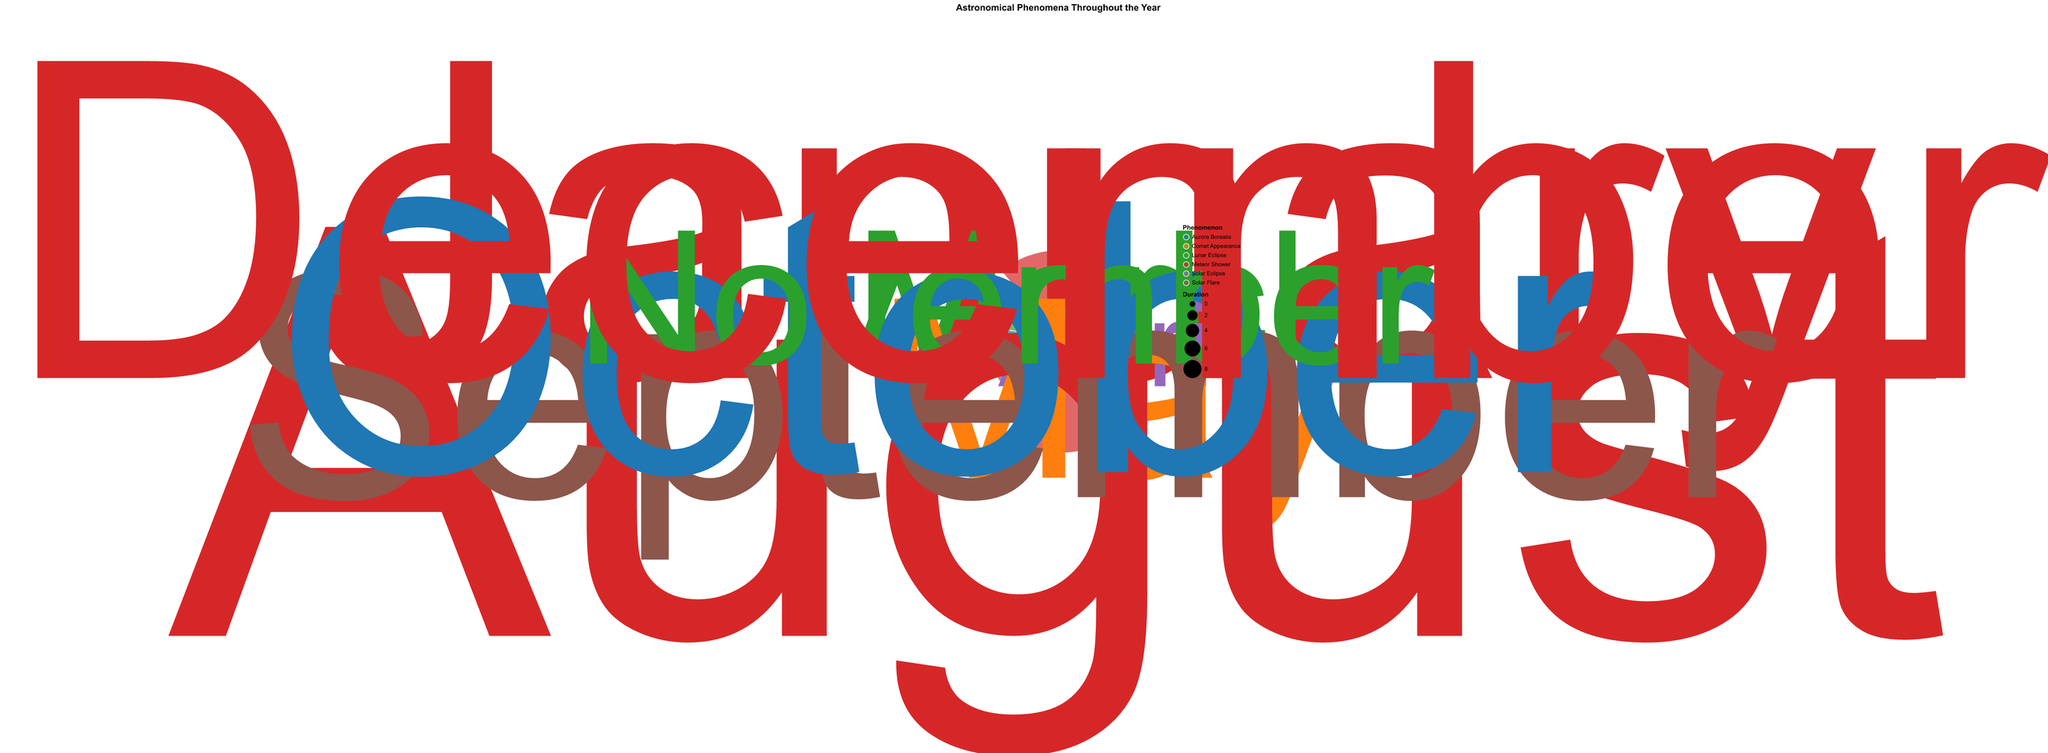What's the title of the figure? The title of the figure is prominently placed at the top of the chart and reads "Astronomical Phenomena Throughout the Year."
Answer: Astronomical Phenomena Throughout the Year Which phenomenon appears most frequently in December? The chart shows different phenomena marked with various colors, and by looking at December, we see that the Meteor Shower has the highest frequency with a count of 3.
Answer: Meteor Shower How many phenomena are recorded in October? In October, the Phenomenon "Aurora Borealis" is recorded, and the color associated with it shows a frequency of 4 on the chart.
Answer: 1 What month has the highest frequency of Meteor Showers? By examining the frequency of Meteor Showers around the polar chart, August shows the highest frequency with 5 occurrences.
Answer: August What months have the occurrence of Lunar Eclipses? The Lunar Eclipse occurrences can be identified in the March and November sections of the chart, each with a frequency of 1.
Answer: March and November What's the total duration of observed Solar Flares throughout the year? Solar Flares are observed in September with a duration of 4 hours. By adding these durations, the total duration is 4 hours.
Answer: 4 hours Compare the frequency of Comet Appearance and Solar Eclipse in May and April, respectively. In May, Comet Appearance has a frequency of 2, whereas in April, Solar Eclipse has a frequency of 1.
Answer: Comet Appearance: 2, Solar Eclipse: 1 What is the difference in duration between Meteor Showers in August and January? August Meteor Showers have a duration of 8 hours, and January's duration is 6 hours. The difference is calculated as 8 - 6 = 2 hours.
Answer: 2 hours Which phenomenon has the longest duration recorded in the year and in which month? By looking at the size (indicating duration) of the phenomena, the Meteor Shower in August shows the largest size corresponding to 8 hours, which is the longest duration.
Answer: Meteor Shower in August What is the average frequency of phenomena recorded in the year? Summing the frequencies of all phenomena (3+1+1+2+5+2+4+1+3 = 22) and dividing by the number of months (9 distinct months), we get the average frequency as 22/9 ≈ 2.44.
Answer: Approximately 2.44 